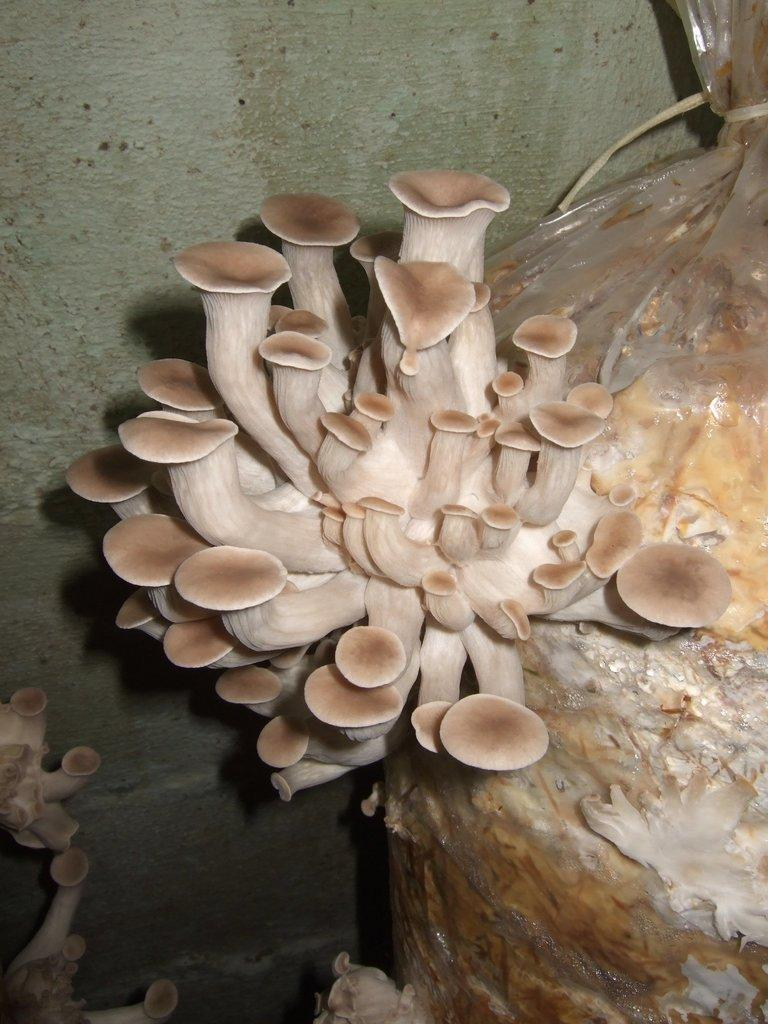What type of fungi can be seen in the image? There are mushrooms in the image. What is covering the mushrooms in the image? There is a cover in the image. What type of structure is visible in the image? There is a wall in the image. What type of meeting is taking place in the image? There is no meeting present in the image; it features mushrooms, a cover, and a wall. How low is the town visible in the image? There is no town present in the image, only mushrooms, a cover, and a wall. 